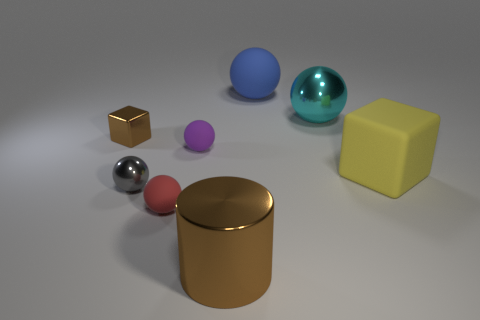Subtract all small purple matte balls. How many balls are left? 4 Subtract all blue balls. How many balls are left? 4 Subtract 2 cubes. How many cubes are left? 0 Subtract all blocks. How many objects are left? 6 Add 2 tiny rubber things. How many tiny rubber things exist? 4 Add 1 small red matte things. How many objects exist? 9 Subtract 1 gray spheres. How many objects are left? 7 Subtract all blue balls. Subtract all cyan cylinders. How many balls are left? 4 Subtract all purple balls. How many purple cylinders are left? 0 Subtract all green rubber blocks. Subtract all matte spheres. How many objects are left? 5 